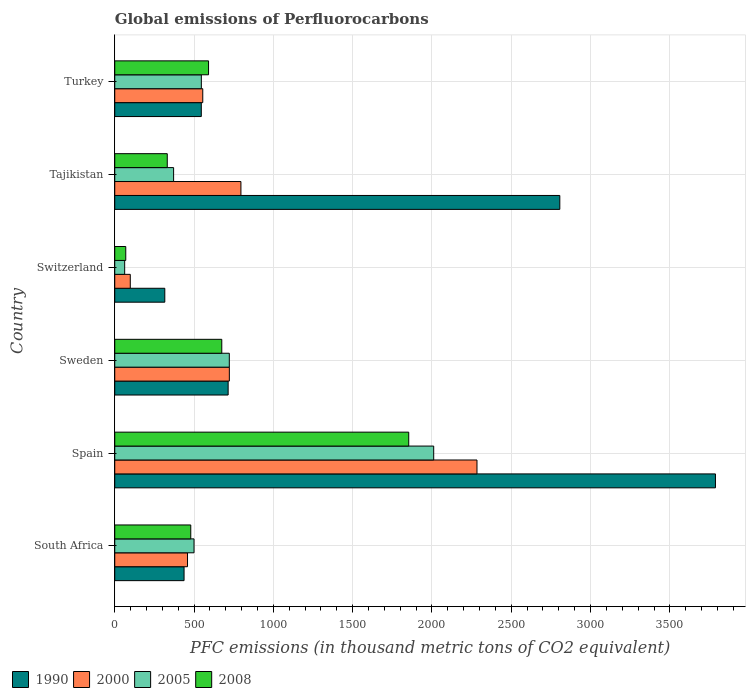Are the number of bars per tick equal to the number of legend labels?
Offer a terse response. Yes. Are the number of bars on each tick of the Y-axis equal?
Ensure brevity in your answer.  Yes. How many bars are there on the 1st tick from the top?
Offer a very short reply. 4. What is the label of the 2nd group of bars from the top?
Ensure brevity in your answer.  Tajikistan. What is the global emissions of Perfluorocarbons in 2000 in South Africa?
Your answer should be compact. 458.8. Across all countries, what is the maximum global emissions of Perfluorocarbons in 2008?
Offer a very short reply. 1853.5. Across all countries, what is the minimum global emissions of Perfluorocarbons in 2000?
Your answer should be compact. 97.9. In which country was the global emissions of Perfluorocarbons in 1990 maximum?
Give a very brief answer. Spain. In which country was the global emissions of Perfluorocarbons in 2008 minimum?
Your answer should be compact. Switzerland. What is the total global emissions of Perfluorocarbons in 1990 in the graph?
Your response must be concise. 8606.5. What is the difference between the global emissions of Perfluorocarbons in 2008 in Tajikistan and that in Turkey?
Offer a terse response. -260.3. What is the difference between the global emissions of Perfluorocarbons in 1990 in Turkey and the global emissions of Perfluorocarbons in 2005 in South Africa?
Make the answer very short. 45.8. What is the average global emissions of Perfluorocarbons in 1990 per country?
Your answer should be compact. 1434.42. What is the ratio of the global emissions of Perfluorocarbons in 2005 in South Africa to that in Tajikistan?
Ensure brevity in your answer.  1.35. Is the difference between the global emissions of Perfluorocarbons in 2005 in Tajikistan and Turkey greater than the difference between the global emissions of Perfluorocarbons in 2008 in Tajikistan and Turkey?
Provide a short and direct response. Yes. What is the difference between the highest and the second highest global emissions of Perfluorocarbons in 2000?
Your response must be concise. 1488.3. What is the difference between the highest and the lowest global emissions of Perfluorocarbons in 1990?
Your response must be concise. 3471.9. In how many countries, is the global emissions of Perfluorocarbons in 2000 greater than the average global emissions of Perfluorocarbons in 2000 taken over all countries?
Keep it short and to the point. 1. Is the sum of the global emissions of Perfluorocarbons in 2005 in Spain and Turkey greater than the maximum global emissions of Perfluorocarbons in 2000 across all countries?
Make the answer very short. Yes. What does the 4th bar from the top in South Africa represents?
Provide a succinct answer. 1990. What does the 4th bar from the bottom in Turkey represents?
Make the answer very short. 2008. How many bars are there?
Your response must be concise. 24. Does the graph contain grids?
Your response must be concise. Yes. Where does the legend appear in the graph?
Give a very brief answer. Bottom left. How many legend labels are there?
Provide a succinct answer. 4. What is the title of the graph?
Provide a short and direct response. Global emissions of Perfluorocarbons. What is the label or title of the X-axis?
Offer a terse response. PFC emissions (in thousand metric tons of CO2 equivalent). What is the PFC emissions (in thousand metric tons of CO2 equivalent) of 1990 in South Africa?
Your response must be concise. 437. What is the PFC emissions (in thousand metric tons of CO2 equivalent) in 2000 in South Africa?
Provide a short and direct response. 458.8. What is the PFC emissions (in thousand metric tons of CO2 equivalent) of 2005 in South Africa?
Offer a terse response. 499.8. What is the PFC emissions (in thousand metric tons of CO2 equivalent) in 2008 in South Africa?
Your answer should be very brief. 479.2. What is the PFC emissions (in thousand metric tons of CO2 equivalent) of 1990 in Spain?
Keep it short and to the point. 3787.4. What is the PFC emissions (in thousand metric tons of CO2 equivalent) of 2000 in Spain?
Make the answer very short. 2283.8. What is the PFC emissions (in thousand metric tons of CO2 equivalent) of 2005 in Spain?
Offer a terse response. 2011. What is the PFC emissions (in thousand metric tons of CO2 equivalent) in 2008 in Spain?
Your response must be concise. 1853.5. What is the PFC emissions (in thousand metric tons of CO2 equivalent) of 1990 in Sweden?
Make the answer very short. 714.9. What is the PFC emissions (in thousand metric tons of CO2 equivalent) in 2000 in Sweden?
Your response must be concise. 722.5. What is the PFC emissions (in thousand metric tons of CO2 equivalent) of 2005 in Sweden?
Provide a short and direct response. 722.3. What is the PFC emissions (in thousand metric tons of CO2 equivalent) of 2008 in Sweden?
Give a very brief answer. 674.8. What is the PFC emissions (in thousand metric tons of CO2 equivalent) in 1990 in Switzerland?
Your answer should be very brief. 315.5. What is the PFC emissions (in thousand metric tons of CO2 equivalent) in 2000 in Switzerland?
Your answer should be compact. 97.9. What is the PFC emissions (in thousand metric tons of CO2 equivalent) in 2005 in Switzerland?
Provide a short and direct response. 62.5. What is the PFC emissions (in thousand metric tons of CO2 equivalent) in 2008 in Switzerland?
Offer a very short reply. 69.4. What is the PFC emissions (in thousand metric tons of CO2 equivalent) in 1990 in Tajikistan?
Ensure brevity in your answer.  2806.1. What is the PFC emissions (in thousand metric tons of CO2 equivalent) in 2000 in Tajikistan?
Your response must be concise. 795.5. What is the PFC emissions (in thousand metric tons of CO2 equivalent) of 2005 in Tajikistan?
Provide a short and direct response. 371.1. What is the PFC emissions (in thousand metric tons of CO2 equivalent) of 2008 in Tajikistan?
Make the answer very short. 331.1. What is the PFC emissions (in thousand metric tons of CO2 equivalent) of 1990 in Turkey?
Your response must be concise. 545.6. What is the PFC emissions (in thousand metric tons of CO2 equivalent) of 2000 in Turkey?
Your answer should be very brief. 554.9. What is the PFC emissions (in thousand metric tons of CO2 equivalent) of 2005 in Turkey?
Offer a very short reply. 545.9. What is the PFC emissions (in thousand metric tons of CO2 equivalent) in 2008 in Turkey?
Keep it short and to the point. 591.4. Across all countries, what is the maximum PFC emissions (in thousand metric tons of CO2 equivalent) in 1990?
Give a very brief answer. 3787.4. Across all countries, what is the maximum PFC emissions (in thousand metric tons of CO2 equivalent) of 2000?
Offer a very short reply. 2283.8. Across all countries, what is the maximum PFC emissions (in thousand metric tons of CO2 equivalent) of 2005?
Your answer should be very brief. 2011. Across all countries, what is the maximum PFC emissions (in thousand metric tons of CO2 equivalent) of 2008?
Provide a succinct answer. 1853.5. Across all countries, what is the minimum PFC emissions (in thousand metric tons of CO2 equivalent) of 1990?
Ensure brevity in your answer.  315.5. Across all countries, what is the minimum PFC emissions (in thousand metric tons of CO2 equivalent) in 2000?
Offer a very short reply. 97.9. Across all countries, what is the minimum PFC emissions (in thousand metric tons of CO2 equivalent) in 2005?
Ensure brevity in your answer.  62.5. Across all countries, what is the minimum PFC emissions (in thousand metric tons of CO2 equivalent) of 2008?
Provide a succinct answer. 69.4. What is the total PFC emissions (in thousand metric tons of CO2 equivalent) of 1990 in the graph?
Make the answer very short. 8606.5. What is the total PFC emissions (in thousand metric tons of CO2 equivalent) in 2000 in the graph?
Your response must be concise. 4913.4. What is the total PFC emissions (in thousand metric tons of CO2 equivalent) of 2005 in the graph?
Provide a succinct answer. 4212.6. What is the total PFC emissions (in thousand metric tons of CO2 equivalent) of 2008 in the graph?
Your answer should be very brief. 3999.4. What is the difference between the PFC emissions (in thousand metric tons of CO2 equivalent) of 1990 in South Africa and that in Spain?
Your answer should be compact. -3350.4. What is the difference between the PFC emissions (in thousand metric tons of CO2 equivalent) in 2000 in South Africa and that in Spain?
Give a very brief answer. -1825. What is the difference between the PFC emissions (in thousand metric tons of CO2 equivalent) in 2005 in South Africa and that in Spain?
Give a very brief answer. -1511.2. What is the difference between the PFC emissions (in thousand metric tons of CO2 equivalent) in 2008 in South Africa and that in Spain?
Your response must be concise. -1374.3. What is the difference between the PFC emissions (in thousand metric tons of CO2 equivalent) in 1990 in South Africa and that in Sweden?
Offer a terse response. -277.9. What is the difference between the PFC emissions (in thousand metric tons of CO2 equivalent) in 2000 in South Africa and that in Sweden?
Give a very brief answer. -263.7. What is the difference between the PFC emissions (in thousand metric tons of CO2 equivalent) in 2005 in South Africa and that in Sweden?
Keep it short and to the point. -222.5. What is the difference between the PFC emissions (in thousand metric tons of CO2 equivalent) in 2008 in South Africa and that in Sweden?
Keep it short and to the point. -195.6. What is the difference between the PFC emissions (in thousand metric tons of CO2 equivalent) of 1990 in South Africa and that in Switzerland?
Offer a terse response. 121.5. What is the difference between the PFC emissions (in thousand metric tons of CO2 equivalent) of 2000 in South Africa and that in Switzerland?
Your answer should be very brief. 360.9. What is the difference between the PFC emissions (in thousand metric tons of CO2 equivalent) in 2005 in South Africa and that in Switzerland?
Keep it short and to the point. 437.3. What is the difference between the PFC emissions (in thousand metric tons of CO2 equivalent) of 2008 in South Africa and that in Switzerland?
Keep it short and to the point. 409.8. What is the difference between the PFC emissions (in thousand metric tons of CO2 equivalent) in 1990 in South Africa and that in Tajikistan?
Ensure brevity in your answer.  -2369.1. What is the difference between the PFC emissions (in thousand metric tons of CO2 equivalent) in 2000 in South Africa and that in Tajikistan?
Keep it short and to the point. -336.7. What is the difference between the PFC emissions (in thousand metric tons of CO2 equivalent) of 2005 in South Africa and that in Tajikistan?
Offer a very short reply. 128.7. What is the difference between the PFC emissions (in thousand metric tons of CO2 equivalent) of 2008 in South Africa and that in Tajikistan?
Provide a short and direct response. 148.1. What is the difference between the PFC emissions (in thousand metric tons of CO2 equivalent) of 1990 in South Africa and that in Turkey?
Offer a very short reply. -108.6. What is the difference between the PFC emissions (in thousand metric tons of CO2 equivalent) of 2000 in South Africa and that in Turkey?
Provide a succinct answer. -96.1. What is the difference between the PFC emissions (in thousand metric tons of CO2 equivalent) of 2005 in South Africa and that in Turkey?
Ensure brevity in your answer.  -46.1. What is the difference between the PFC emissions (in thousand metric tons of CO2 equivalent) of 2008 in South Africa and that in Turkey?
Offer a very short reply. -112.2. What is the difference between the PFC emissions (in thousand metric tons of CO2 equivalent) of 1990 in Spain and that in Sweden?
Ensure brevity in your answer.  3072.5. What is the difference between the PFC emissions (in thousand metric tons of CO2 equivalent) in 2000 in Spain and that in Sweden?
Offer a very short reply. 1561.3. What is the difference between the PFC emissions (in thousand metric tons of CO2 equivalent) in 2005 in Spain and that in Sweden?
Provide a short and direct response. 1288.7. What is the difference between the PFC emissions (in thousand metric tons of CO2 equivalent) of 2008 in Spain and that in Sweden?
Ensure brevity in your answer.  1178.7. What is the difference between the PFC emissions (in thousand metric tons of CO2 equivalent) of 1990 in Spain and that in Switzerland?
Your answer should be compact. 3471.9. What is the difference between the PFC emissions (in thousand metric tons of CO2 equivalent) in 2000 in Spain and that in Switzerland?
Provide a succinct answer. 2185.9. What is the difference between the PFC emissions (in thousand metric tons of CO2 equivalent) of 2005 in Spain and that in Switzerland?
Your answer should be compact. 1948.5. What is the difference between the PFC emissions (in thousand metric tons of CO2 equivalent) in 2008 in Spain and that in Switzerland?
Offer a terse response. 1784.1. What is the difference between the PFC emissions (in thousand metric tons of CO2 equivalent) of 1990 in Spain and that in Tajikistan?
Provide a succinct answer. 981.3. What is the difference between the PFC emissions (in thousand metric tons of CO2 equivalent) of 2000 in Spain and that in Tajikistan?
Provide a succinct answer. 1488.3. What is the difference between the PFC emissions (in thousand metric tons of CO2 equivalent) in 2005 in Spain and that in Tajikistan?
Keep it short and to the point. 1639.9. What is the difference between the PFC emissions (in thousand metric tons of CO2 equivalent) of 2008 in Spain and that in Tajikistan?
Give a very brief answer. 1522.4. What is the difference between the PFC emissions (in thousand metric tons of CO2 equivalent) in 1990 in Spain and that in Turkey?
Make the answer very short. 3241.8. What is the difference between the PFC emissions (in thousand metric tons of CO2 equivalent) of 2000 in Spain and that in Turkey?
Your answer should be compact. 1728.9. What is the difference between the PFC emissions (in thousand metric tons of CO2 equivalent) in 2005 in Spain and that in Turkey?
Keep it short and to the point. 1465.1. What is the difference between the PFC emissions (in thousand metric tons of CO2 equivalent) of 2008 in Spain and that in Turkey?
Offer a very short reply. 1262.1. What is the difference between the PFC emissions (in thousand metric tons of CO2 equivalent) in 1990 in Sweden and that in Switzerland?
Offer a very short reply. 399.4. What is the difference between the PFC emissions (in thousand metric tons of CO2 equivalent) in 2000 in Sweden and that in Switzerland?
Your response must be concise. 624.6. What is the difference between the PFC emissions (in thousand metric tons of CO2 equivalent) in 2005 in Sweden and that in Switzerland?
Offer a very short reply. 659.8. What is the difference between the PFC emissions (in thousand metric tons of CO2 equivalent) in 2008 in Sweden and that in Switzerland?
Your answer should be very brief. 605.4. What is the difference between the PFC emissions (in thousand metric tons of CO2 equivalent) in 1990 in Sweden and that in Tajikistan?
Your response must be concise. -2091.2. What is the difference between the PFC emissions (in thousand metric tons of CO2 equivalent) in 2000 in Sweden and that in Tajikistan?
Give a very brief answer. -73. What is the difference between the PFC emissions (in thousand metric tons of CO2 equivalent) of 2005 in Sweden and that in Tajikistan?
Provide a short and direct response. 351.2. What is the difference between the PFC emissions (in thousand metric tons of CO2 equivalent) of 2008 in Sweden and that in Tajikistan?
Your answer should be compact. 343.7. What is the difference between the PFC emissions (in thousand metric tons of CO2 equivalent) of 1990 in Sweden and that in Turkey?
Make the answer very short. 169.3. What is the difference between the PFC emissions (in thousand metric tons of CO2 equivalent) of 2000 in Sweden and that in Turkey?
Make the answer very short. 167.6. What is the difference between the PFC emissions (in thousand metric tons of CO2 equivalent) in 2005 in Sweden and that in Turkey?
Your answer should be very brief. 176.4. What is the difference between the PFC emissions (in thousand metric tons of CO2 equivalent) in 2008 in Sweden and that in Turkey?
Provide a succinct answer. 83.4. What is the difference between the PFC emissions (in thousand metric tons of CO2 equivalent) in 1990 in Switzerland and that in Tajikistan?
Offer a terse response. -2490.6. What is the difference between the PFC emissions (in thousand metric tons of CO2 equivalent) in 2000 in Switzerland and that in Tajikistan?
Your response must be concise. -697.6. What is the difference between the PFC emissions (in thousand metric tons of CO2 equivalent) in 2005 in Switzerland and that in Tajikistan?
Your response must be concise. -308.6. What is the difference between the PFC emissions (in thousand metric tons of CO2 equivalent) of 2008 in Switzerland and that in Tajikistan?
Provide a short and direct response. -261.7. What is the difference between the PFC emissions (in thousand metric tons of CO2 equivalent) in 1990 in Switzerland and that in Turkey?
Make the answer very short. -230.1. What is the difference between the PFC emissions (in thousand metric tons of CO2 equivalent) of 2000 in Switzerland and that in Turkey?
Your answer should be very brief. -457. What is the difference between the PFC emissions (in thousand metric tons of CO2 equivalent) in 2005 in Switzerland and that in Turkey?
Your answer should be very brief. -483.4. What is the difference between the PFC emissions (in thousand metric tons of CO2 equivalent) in 2008 in Switzerland and that in Turkey?
Ensure brevity in your answer.  -522. What is the difference between the PFC emissions (in thousand metric tons of CO2 equivalent) in 1990 in Tajikistan and that in Turkey?
Offer a very short reply. 2260.5. What is the difference between the PFC emissions (in thousand metric tons of CO2 equivalent) of 2000 in Tajikistan and that in Turkey?
Your answer should be very brief. 240.6. What is the difference between the PFC emissions (in thousand metric tons of CO2 equivalent) in 2005 in Tajikistan and that in Turkey?
Your answer should be very brief. -174.8. What is the difference between the PFC emissions (in thousand metric tons of CO2 equivalent) in 2008 in Tajikistan and that in Turkey?
Offer a very short reply. -260.3. What is the difference between the PFC emissions (in thousand metric tons of CO2 equivalent) in 1990 in South Africa and the PFC emissions (in thousand metric tons of CO2 equivalent) in 2000 in Spain?
Keep it short and to the point. -1846.8. What is the difference between the PFC emissions (in thousand metric tons of CO2 equivalent) in 1990 in South Africa and the PFC emissions (in thousand metric tons of CO2 equivalent) in 2005 in Spain?
Your answer should be very brief. -1574. What is the difference between the PFC emissions (in thousand metric tons of CO2 equivalent) of 1990 in South Africa and the PFC emissions (in thousand metric tons of CO2 equivalent) of 2008 in Spain?
Give a very brief answer. -1416.5. What is the difference between the PFC emissions (in thousand metric tons of CO2 equivalent) of 2000 in South Africa and the PFC emissions (in thousand metric tons of CO2 equivalent) of 2005 in Spain?
Your answer should be very brief. -1552.2. What is the difference between the PFC emissions (in thousand metric tons of CO2 equivalent) of 2000 in South Africa and the PFC emissions (in thousand metric tons of CO2 equivalent) of 2008 in Spain?
Make the answer very short. -1394.7. What is the difference between the PFC emissions (in thousand metric tons of CO2 equivalent) of 2005 in South Africa and the PFC emissions (in thousand metric tons of CO2 equivalent) of 2008 in Spain?
Give a very brief answer. -1353.7. What is the difference between the PFC emissions (in thousand metric tons of CO2 equivalent) of 1990 in South Africa and the PFC emissions (in thousand metric tons of CO2 equivalent) of 2000 in Sweden?
Your response must be concise. -285.5. What is the difference between the PFC emissions (in thousand metric tons of CO2 equivalent) of 1990 in South Africa and the PFC emissions (in thousand metric tons of CO2 equivalent) of 2005 in Sweden?
Your response must be concise. -285.3. What is the difference between the PFC emissions (in thousand metric tons of CO2 equivalent) of 1990 in South Africa and the PFC emissions (in thousand metric tons of CO2 equivalent) of 2008 in Sweden?
Your answer should be very brief. -237.8. What is the difference between the PFC emissions (in thousand metric tons of CO2 equivalent) of 2000 in South Africa and the PFC emissions (in thousand metric tons of CO2 equivalent) of 2005 in Sweden?
Offer a terse response. -263.5. What is the difference between the PFC emissions (in thousand metric tons of CO2 equivalent) in 2000 in South Africa and the PFC emissions (in thousand metric tons of CO2 equivalent) in 2008 in Sweden?
Make the answer very short. -216. What is the difference between the PFC emissions (in thousand metric tons of CO2 equivalent) in 2005 in South Africa and the PFC emissions (in thousand metric tons of CO2 equivalent) in 2008 in Sweden?
Offer a terse response. -175. What is the difference between the PFC emissions (in thousand metric tons of CO2 equivalent) in 1990 in South Africa and the PFC emissions (in thousand metric tons of CO2 equivalent) in 2000 in Switzerland?
Your answer should be compact. 339.1. What is the difference between the PFC emissions (in thousand metric tons of CO2 equivalent) in 1990 in South Africa and the PFC emissions (in thousand metric tons of CO2 equivalent) in 2005 in Switzerland?
Give a very brief answer. 374.5. What is the difference between the PFC emissions (in thousand metric tons of CO2 equivalent) of 1990 in South Africa and the PFC emissions (in thousand metric tons of CO2 equivalent) of 2008 in Switzerland?
Provide a succinct answer. 367.6. What is the difference between the PFC emissions (in thousand metric tons of CO2 equivalent) in 2000 in South Africa and the PFC emissions (in thousand metric tons of CO2 equivalent) in 2005 in Switzerland?
Provide a succinct answer. 396.3. What is the difference between the PFC emissions (in thousand metric tons of CO2 equivalent) in 2000 in South Africa and the PFC emissions (in thousand metric tons of CO2 equivalent) in 2008 in Switzerland?
Your answer should be very brief. 389.4. What is the difference between the PFC emissions (in thousand metric tons of CO2 equivalent) of 2005 in South Africa and the PFC emissions (in thousand metric tons of CO2 equivalent) of 2008 in Switzerland?
Your response must be concise. 430.4. What is the difference between the PFC emissions (in thousand metric tons of CO2 equivalent) in 1990 in South Africa and the PFC emissions (in thousand metric tons of CO2 equivalent) in 2000 in Tajikistan?
Ensure brevity in your answer.  -358.5. What is the difference between the PFC emissions (in thousand metric tons of CO2 equivalent) in 1990 in South Africa and the PFC emissions (in thousand metric tons of CO2 equivalent) in 2005 in Tajikistan?
Make the answer very short. 65.9. What is the difference between the PFC emissions (in thousand metric tons of CO2 equivalent) of 1990 in South Africa and the PFC emissions (in thousand metric tons of CO2 equivalent) of 2008 in Tajikistan?
Ensure brevity in your answer.  105.9. What is the difference between the PFC emissions (in thousand metric tons of CO2 equivalent) of 2000 in South Africa and the PFC emissions (in thousand metric tons of CO2 equivalent) of 2005 in Tajikistan?
Your response must be concise. 87.7. What is the difference between the PFC emissions (in thousand metric tons of CO2 equivalent) in 2000 in South Africa and the PFC emissions (in thousand metric tons of CO2 equivalent) in 2008 in Tajikistan?
Ensure brevity in your answer.  127.7. What is the difference between the PFC emissions (in thousand metric tons of CO2 equivalent) in 2005 in South Africa and the PFC emissions (in thousand metric tons of CO2 equivalent) in 2008 in Tajikistan?
Make the answer very short. 168.7. What is the difference between the PFC emissions (in thousand metric tons of CO2 equivalent) of 1990 in South Africa and the PFC emissions (in thousand metric tons of CO2 equivalent) of 2000 in Turkey?
Your answer should be very brief. -117.9. What is the difference between the PFC emissions (in thousand metric tons of CO2 equivalent) of 1990 in South Africa and the PFC emissions (in thousand metric tons of CO2 equivalent) of 2005 in Turkey?
Offer a terse response. -108.9. What is the difference between the PFC emissions (in thousand metric tons of CO2 equivalent) in 1990 in South Africa and the PFC emissions (in thousand metric tons of CO2 equivalent) in 2008 in Turkey?
Your answer should be compact. -154.4. What is the difference between the PFC emissions (in thousand metric tons of CO2 equivalent) in 2000 in South Africa and the PFC emissions (in thousand metric tons of CO2 equivalent) in 2005 in Turkey?
Ensure brevity in your answer.  -87.1. What is the difference between the PFC emissions (in thousand metric tons of CO2 equivalent) of 2000 in South Africa and the PFC emissions (in thousand metric tons of CO2 equivalent) of 2008 in Turkey?
Keep it short and to the point. -132.6. What is the difference between the PFC emissions (in thousand metric tons of CO2 equivalent) in 2005 in South Africa and the PFC emissions (in thousand metric tons of CO2 equivalent) in 2008 in Turkey?
Your answer should be compact. -91.6. What is the difference between the PFC emissions (in thousand metric tons of CO2 equivalent) of 1990 in Spain and the PFC emissions (in thousand metric tons of CO2 equivalent) of 2000 in Sweden?
Ensure brevity in your answer.  3064.9. What is the difference between the PFC emissions (in thousand metric tons of CO2 equivalent) of 1990 in Spain and the PFC emissions (in thousand metric tons of CO2 equivalent) of 2005 in Sweden?
Ensure brevity in your answer.  3065.1. What is the difference between the PFC emissions (in thousand metric tons of CO2 equivalent) in 1990 in Spain and the PFC emissions (in thousand metric tons of CO2 equivalent) in 2008 in Sweden?
Your answer should be very brief. 3112.6. What is the difference between the PFC emissions (in thousand metric tons of CO2 equivalent) in 2000 in Spain and the PFC emissions (in thousand metric tons of CO2 equivalent) in 2005 in Sweden?
Ensure brevity in your answer.  1561.5. What is the difference between the PFC emissions (in thousand metric tons of CO2 equivalent) in 2000 in Spain and the PFC emissions (in thousand metric tons of CO2 equivalent) in 2008 in Sweden?
Make the answer very short. 1609. What is the difference between the PFC emissions (in thousand metric tons of CO2 equivalent) in 2005 in Spain and the PFC emissions (in thousand metric tons of CO2 equivalent) in 2008 in Sweden?
Your answer should be compact. 1336.2. What is the difference between the PFC emissions (in thousand metric tons of CO2 equivalent) of 1990 in Spain and the PFC emissions (in thousand metric tons of CO2 equivalent) of 2000 in Switzerland?
Your answer should be very brief. 3689.5. What is the difference between the PFC emissions (in thousand metric tons of CO2 equivalent) in 1990 in Spain and the PFC emissions (in thousand metric tons of CO2 equivalent) in 2005 in Switzerland?
Keep it short and to the point. 3724.9. What is the difference between the PFC emissions (in thousand metric tons of CO2 equivalent) in 1990 in Spain and the PFC emissions (in thousand metric tons of CO2 equivalent) in 2008 in Switzerland?
Give a very brief answer. 3718. What is the difference between the PFC emissions (in thousand metric tons of CO2 equivalent) in 2000 in Spain and the PFC emissions (in thousand metric tons of CO2 equivalent) in 2005 in Switzerland?
Your response must be concise. 2221.3. What is the difference between the PFC emissions (in thousand metric tons of CO2 equivalent) of 2000 in Spain and the PFC emissions (in thousand metric tons of CO2 equivalent) of 2008 in Switzerland?
Offer a very short reply. 2214.4. What is the difference between the PFC emissions (in thousand metric tons of CO2 equivalent) of 2005 in Spain and the PFC emissions (in thousand metric tons of CO2 equivalent) of 2008 in Switzerland?
Provide a short and direct response. 1941.6. What is the difference between the PFC emissions (in thousand metric tons of CO2 equivalent) of 1990 in Spain and the PFC emissions (in thousand metric tons of CO2 equivalent) of 2000 in Tajikistan?
Provide a short and direct response. 2991.9. What is the difference between the PFC emissions (in thousand metric tons of CO2 equivalent) of 1990 in Spain and the PFC emissions (in thousand metric tons of CO2 equivalent) of 2005 in Tajikistan?
Your answer should be very brief. 3416.3. What is the difference between the PFC emissions (in thousand metric tons of CO2 equivalent) of 1990 in Spain and the PFC emissions (in thousand metric tons of CO2 equivalent) of 2008 in Tajikistan?
Keep it short and to the point. 3456.3. What is the difference between the PFC emissions (in thousand metric tons of CO2 equivalent) of 2000 in Spain and the PFC emissions (in thousand metric tons of CO2 equivalent) of 2005 in Tajikistan?
Offer a terse response. 1912.7. What is the difference between the PFC emissions (in thousand metric tons of CO2 equivalent) of 2000 in Spain and the PFC emissions (in thousand metric tons of CO2 equivalent) of 2008 in Tajikistan?
Your answer should be very brief. 1952.7. What is the difference between the PFC emissions (in thousand metric tons of CO2 equivalent) in 2005 in Spain and the PFC emissions (in thousand metric tons of CO2 equivalent) in 2008 in Tajikistan?
Provide a succinct answer. 1679.9. What is the difference between the PFC emissions (in thousand metric tons of CO2 equivalent) in 1990 in Spain and the PFC emissions (in thousand metric tons of CO2 equivalent) in 2000 in Turkey?
Offer a terse response. 3232.5. What is the difference between the PFC emissions (in thousand metric tons of CO2 equivalent) of 1990 in Spain and the PFC emissions (in thousand metric tons of CO2 equivalent) of 2005 in Turkey?
Provide a short and direct response. 3241.5. What is the difference between the PFC emissions (in thousand metric tons of CO2 equivalent) in 1990 in Spain and the PFC emissions (in thousand metric tons of CO2 equivalent) in 2008 in Turkey?
Your answer should be compact. 3196. What is the difference between the PFC emissions (in thousand metric tons of CO2 equivalent) in 2000 in Spain and the PFC emissions (in thousand metric tons of CO2 equivalent) in 2005 in Turkey?
Ensure brevity in your answer.  1737.9. What is the difference between the PFC emissions (in thousand metric tons of CO2 equivalent) in 2000 in Spain and the PFC emissions (in thousand metric tons of CO2 equivalent) in 2008 in Turkey?
Your answer should be very brief. 1692.4. What is the difference between the PFC emissions (in thousand metric tons of CO2 equivalent) of 2005 in Spain and the PFC emissions (in thousand metric tons of CO2 equivalent) of 2008 in Turkey?
Ensure brevity in your answer.  1419.6. What is the difference between the PFC emissions (in thousand metric tons of CO2 equivalent) of 1990 in Sweden and the PFC emissions (in thousand metric tons of CO2 equivalent) of 2000 in Switzerland?
Keep it short and to the point. 617. What is the difference between the PFC emissions (in thousand metric tons of CO2 equivalent) in 1990 in Sweden and the PFC emissions (in thousand metric tons of CO2 equivalent) in 2005 in Switzerland?
Your response must be concise. 652.4. What is the difference between the PFC emissions (in thousand metric tons of CO2 equivalent) of 1990 in Sweden and the PFC emissions (in thousand metric tons of CO2 equivalent) of 2008 in Switzerland?
Make the answer very short. 645.5. What is the difference between the PFC emissions (in thousand metric tons of CO2 equivalent) in 2000 in Sweden and the PFC emissions (in thousand metric tons of CO2 equivalent) in 2005 in Switzerland?
Give a very brief answer. 660. What is the difference between the PFC emissions (in thousand metric tons of CO2 equivalent) in 2000 in Sweden and the PFC emissions (in thousand metric tons of CO2 equivalent) in 2008 in Switzerland?
Provide a short and direct response. 653.1. What is the difference between the PFC emissions (in thousand metric tons of CO2 equivalent) in 2005 in Sweden and the PFC emissions (in thousand metric tons of CO2 equivalent) in 2008 in Switzerland?
Offer a very short reply. 652.9. What is the difference between the PFC emissions (in thousand metric tons of CO2 equivalent) in 1990 in Sweden and the PFC emissions (in thousand metric tons of CO2 equivalent) in 2000 in Tajikistan?
Ensure brevity in your answer.  -80.6. What is the difference between the PFC emissions (in thousand metric tons of CO2 equivalent) of 1990 in Sweden and the PFC emissions (in thousand metric tons of CO2 equivalent) of 2005 in Tajikistan?
Offer a terse response. 343.8. What is the difference between the PFC emissions (in thousand metric tons of CO2 equivalent) in 1990 in Sweden and the PFC emissions (in thousand metric tons of CO2 equivalent) in 2008 in Tajikistan?
Ensure brevity in your answer.  383.8. What is the difference between the PFC emissions (in thousand metric tons of CO2 equivalent) of 2000 in Sweden and the PFC emissions (in thousand metric tons of CO2 equivalent) of 2005 in Tajikistan?
Your answer should be compact. 351.4. What is the difference between the PFC emissions (in thousand metric tons of CO2 equivalent) in 2000 in Sweden and the PFC emissions (in thousand metric tons of CO2 equivalent) in 2008 in Tajikistan?
Offer a very short reply. 391.4. What is the difference between the PFC emissions (in thousand metric tons of CO2 equivalent) in 2005 in Sweden and the PFC emissions (in thousand metric tons of CO2 equivalent) in 2008 in Tajikistan?
Give a very brief answer. 391.2. What is the difference between the PFC emissions (in thousand metric tons of CO2 equivalent) in 1990 in Sweden and the PFC emissions (in thousand metric tons of CO2 equivalent) in 2000 in Turkey?
Your answer should be compact. 160. What is the difference between the PFC emissions (in thousand metric tons of CO2 equivalent) of 1990 in Sweden and the PFC emissions (in thousand metric tons of CO2 equivalent) of 2005 in Turkey?
Your response must be concise. 169. What is the difference between the PFC emissions (in thousand metric tons of CO2 equivalent) in 1990 in Sweden and the PFC emissions (in thousand metric tons of CO2 equivalent) in 2008 in Turkey?
Ensure brevity in your answer.  123.5. What is the difference between the PFC emissions (in thousand metric tons of CO2 equivalent) in 2000 in Sweden and the PFC emissions (in thousand metric tons of CO2 equivalent) in 2005 in Turkey?
Your answer should be very brief. 176.6. What is the difference between the PFC emissions (in thousand metric tons of CO2 equivalent) of 2000 in Sweden and the PFC emissions (in thousand metric tons of CO2 equivalent) of 2008 in Turkey?
Your answer should be compact. 131.1. What is the difference between the PFC emissions (in thousand metric tons of CO2 equivalent) of 2005 in Sweden and the PFC emissions (in thousand metric tons of CO2 equivalent) of 2008 in Turkey?
Provide a short and direct response. 130.9. What is the difference between the PFC emissions (in thousand metric tons of CO2 equivalent) in 1990 in Switzerland and the PFC emissions (in thousand metric tons of CO2 equivalent) in 2000 in Tajikistan?
Make the answer very short. -480. What is the difference between the PFC emissions (in thousand metric tons of CO2 equivalent) in 1990 in Switzerland and the PFC emissions (in thousand metric tons of CO2 equivalent) in 2005 in Tajikistan?
Keep it short and to the point. -55.6. What is the difference between the PFC emissions (in thousand metric tons of CO2 equivalent) of 1990 in Switzerland and the PFC emissions (in thousand metric tons of CO2 equivalent) of 2008 in Tajikistan?
Give a very brief answer. -15.6. What is the difference between the PFC emissions (in thousand metric tons of CO2 equivalent) in 2000 in Switzerland and the PFC emissions (in thousand metric tons of CO2 equivalent) in 2005 in Tajikistan?
Give a very brief answer. -273.2. What is the difference between the PFC emissions (in thousand metric tons of CO2 equivalent) in 2000 in Switzerland and the PFC emissions (in thousand metric tons of CO2 equivalent) in 2008 in Tajikistan?
Provide a succinct answer. -233.2. What is the difference between the PFC emissions (in thousand metric tons of CO2 equivalent) in 2005 in Switzerland and the PFC emissions (in thousand metric tons of CO2 equivalent) in 2008 in Tajikistan?
Give a very brief answer. -268.6. What is the difference between the PFC emissions (in thousand metric tons of CO2 equivalent) of 1990 in Switzerland and the PFC emissions (in thousand metric tons of CO2 equivalent) of 2000 in Turkey?
Your answer should be very brief. -239.4. What is the difference between the PFC emissions (in thousand metric tons of CO2 equivalent) in 1990 in Switzerland and the PFC emissions (in thousand metric tons of CO2 equivalent) in 2005 in Turkey?
Keep it short and to the point. -230.4. What is the difference between the PFC emissions (in thousand metric tons of CO2 equivalent) of 1990 in Switzerland and the PFC emissions (in thousand metric tons of CO2 equivalent) of 2008 in Turkey?
Keep it short and to the point. -275.9. What is the difference between the PFC emissions (in thousand metric tons of CO2 equivalent) in 2000 in Switzerland and the PFC emissions (in thousand metric tons of CO2 equivalent) in 2005 in Turkey?
Give a very brief answer. -448. What is the difference between the PFC emissions (in thousand metric tons of CO2 equivalent) in 2000 in Switzerland and the PFC emissions (in thousand metric tons of CO2 equivalent) in 2008 in Turkey?
Make the answer very short. -493.5. What is the difference between the PFC emissions (in thousand metric tons of CO2 equivalent) of 2005 in Switzerland and the PFC emissions (in thousand metric tons of CO2 equivalent) of 2008 in Turkey?
Offer a very short reply. -528.9. What is the difference between the PFC emissions (in thousand metric tons of CO2 equivalent) of 1990 in Tajikistan and the PFC emissions (in thousand metric tons of CO2 equivalent) of 2000 in Turkey?
Ensure brevity in your answer.  2251.2. What is the difference between the PFC emissions (in thousand metric tons of CO2 equivalent) of 1990 in Tajikistan and the PFC emissions (in thousand metric tons of CO2 equivalent) of 2005 in Turkey?
Make the answer very short. 2260.2. What is the difference between the PFC emissions (in thousand metric tons of CO2 equivalent) of 1990 in Tajikistan and the PFC emissions (in thousand metric tons of CO2 equivalent) of 2008 in Turkey?
Make the answer very short. 2214.7. What is the difference between the PFC emissions (in thousand metric tons of CO2 equivalent) in 2000 in Tajikistan and the PFC emissions (in thousand metric tons of CO2 equivalent) in 2005 in Turkey?
Your answer should be compact. 249.6. What is the difference between the PFC emissions (in thousand metric tons of CO2 equivalent) of 2000 in Tajikistan and the PFC emissions (in thousand metric tons of CO2 equivalent) of 2008 in Turkey?
Make the answer very short. 204.1. What is the difference between the PFC emissions (in thousand metric tons of CO2 equivalent) of 2005 in Tajikistan and the PFC emissions (in thousand metric tons of CO2 equivalent) of 2008 in Turkey?
Offer a very short reply. -220.3. What is the average PFC emissions (in thousand metric tons of CO2 equivalent) in 1990 per country?
Offer a terse response. 1434.42. What is the average PFC emissions (in thousand metric tons of CO2 equivalent) of 2000 per country?
Your response must be concise. 818.9. What is the average PFC emissions (in thousand metric tons of CO2 equivalent) in 2005 per country?
Make the answer very short. 702.1. What is the average PFC emissions (in thousand metric tons of CO2 equivalent) in 2008 per country?
Offer a terse response. 666.57. What is the difference between the PFC emissions (in thousand metric tons of CO2 equivalent) of 1990 and PFC emissions (in thousand metric tons of CO2 equivalent) of 2000 in South Africa?
Ensure brevity in your answer.  -21.8. What is the difference between the PFC emissions (in thousand metric tons of CO2 equivalent) in 1990 and PFC emissions (in thousand metric tons of CO2 equivalent) in 2005 in South Africa?
Your response must be concise. -62.8. What is the difference between the PFC emissions (in thousand metric tons of CO2 equivalent) in 1990 and PFC emissions (in thousand metric tons of CO2 equivalent) in 2008 in South Africa?
Provide a short and direct response. -42.2. What is the difference between the PFC emissions (in thousand metric tons of CO2 equivalent) in 2000 and PFC emissions (in thousand metric tons of CO2 equivalent) in 2005 in South Africa?
Give a very brief answer. -41. What is the difference between the PFC emissions (in thousand metric tons of CO2 equivalent) of 2000 and PFC emissions (in thousand metric tons of CO2 equivalent) of 2008 in South Africa?
Provide a succinct answer. -20.4. What is the difference between the PFC emissions (in thousand metric tons of CO2 equivalent) in 2005 and PFC emissions (in thousand metric tons of CO2 equivalent) in 2008 in South Africa?
Provide a succinct answer. 20.6. What is the difference between the PFC emissions (in thousand metric tons of CO2 equivalent) of 1990 and PFC emissions (in thousand metric tons of CO2 equivalent) of 2000 in Spain?
Provide a short and direct response. 1503.6. What is the difference between the PFC emissions (in thousand metric tons of CO2 equivalent) of 1990 and PFC emissions (in thousand metric tons of CO2 equivalent) of 2005 in Spain?
Your answer should be compact. 1776.4. What is the difference between the PFC emissions (in thousand metric tons of CO2 equivalent) of 1990 and PFC emissions (in thousand metric tons of CO2 equivalent) of 2008 in Spain?
Provide a short and direct response. 1933.9. What is the difference between the PFC emissions (in thousand metric tons of CO2 equivalent) of 2000 and PFC emissions (in thousand metric tons of CO2 equivalent) of 2005 in Spain?
Provide a succinct answer. 272.8. What is the difference between the PFC emissions (in thousand metric tons of CO2 equivalent) in 2000 and PFC emissions (in thousand metric tons of CO2 equivalent) in 2008 in Spain?
Your answer should be very brief. 430.3. What is the difference between the PFC emissions (in thousand metric tons of CO2 equivalent) of 2005 and PFC emissions (in thousand metric tons of CO2 equivalent) of 2008 in Spain?
Your answer should be compact. 157.5. What is the difference between the PFC emissions (in thousand metric tons of CO2 equivalent) in 1990 and PFC emissions (in thousand metric tons of CO2 equivalent) in 2008 in Sweden?
Keep it short and to the point. 40.1. What is the difference between the PFC emissions (in thousand metric tons of CO2 equivalent) in 2000 and PFC emissions (in thousand metric tons of CO2 equivalent) in 2008 in Sweden?
Keep it short and to the point. 47.7. What is the difference between the PFC emissions (in thousand metric tons of CO2 equivalent) of 2005 and PFC emissions (in thousand metric tons of CO2 equivalent) of 2008 in Sweden?
Provide a succinct answer. 47.5. What is the difference between the PFC emissions (in thousand metric tons of CO2 equivalent) of 1990 and PFC emissions (in thousand metric tons of CO2 equivalent) of 2000 in Switzerland?
Keep it short and to the point. 217.6. What is the difference between the PFC emissions (in thousand metric tons of CO2 equivalent) in 1990 and PFC emissions (in thousand metric tons of CO2 equivalent) in 2005 in Switzerland?
Your response must be concise. 253. What is the difference between the PFC emissions (in thousand metric tons of CO2 equivalent) in 1990 and PFC emissions (in thousand metric tons of CO2 equivalent) in 2008 in Switzerland?
Your answer should be compact. 246.1. What is the difference between the PFC emissions (in thousand metric tons of CO2 equivalent) in 2000 and PFC emissions (in thousand metric tons of CO2 equivalent) in 2005 in Switzerland?
Offer a very short reply. 35.4. What is the difference between the PFC emissions (in thousand metric tons of CO2 equivalent) in 2000 and PFC emissions (in thousand metric tons of CO2 equivalent) in 2008 in Switzerland?
Ensure brevity in your answer.  28.5. What is the difference between the PFC emissions (in thousand metric tons of CO2 equivalent) of 2005 and PFC emissions (in thousand metric tons of CO2 equivalent) of 2008 in Switzerland?
Your answer should be compact. -6.9. What is the difference between the PFC emissions (in thousand metric tons of CO2 equivalent) in 1990 and PFC emissions (in thousand metric tons of CO2 equivalent) in 2000 in Tajikistan?
Make the answer very short. 2010.6. What is the difference between the PFC emissions (in thousand metric tons of CO2 equivalent) in 1990 and PFC emissions (in thousand metric tons of CO2 equivalent) in 2005 in Tajikistan?
Ensure brevity in your answer.  2435. What is the difference between the PFC emissions (in thousand metric tons of CO2 equivalent) in 1990 and PFC emissions (in thousand metric tons of CO2 equivalent) in 2008 in Tajikistan?
Make the answer very short. 2475. What is the difference between the PFC emissions (in thousand metric tons of CO2 equivalent) in 2000 and PFC emissions (in thousand metric tons of CO2 equivalent) in 2005 in Tajikistan?
Ensure brevity in your answer.  424.4. What is the difference between the PFC emissions (in thousand metric tons of CO2 equivalent) in 2000 and PFC emissions (in thousand metric tons of CO2 equivalent) in 2008 in Tajikistan?
Ensure brevity in your answer.  464.4. What is the difference between the PFC emissions (in thousand metric tons of CO2 equivalent) in 2005 and PFC emissions (in thousand metric tons of CO2 equivalent) in 2008 in Tajikistan?
Your answer should be very brief. 40. What is the difference between the PFC emissions (in thousand metric tons of CO2 equivalent) in 1990 and PFC emissions (in thousand metric tons of CO2 equivalent) in 2008 in Turkey?
Provide a succinct answer. -45.8. What is the difference between the PFC emissions (in thousand metric tons of CO2 equivalent) of 2000 and PFC emissions (in thousand metric tons of CO2 equivalent) of 2008 in Turkey?
Offer a terse response. -36.5. What is the difference between the PFC emissions (in thousand metric tons of CO2 equivalent) in 2005 and PFC emissions (in thousand metric tons of CO2 equivalent) in 2008 in Turkey?
Your response must be concise. -45.5. What is the ratio of the PFC emissions (in thousand metric tons of CO2 equivalent) of 1990 in South Africa to that in Spain?
Your answer should be compact. 0.12. What is the ratio of the PFC emissions (in thousand metric tons of CO2 equivalent) of 2000 in South Africa to that in Spain?
Provide a succinct answer. 0.2. What is the ratio of the PFC emissions (in thousand metric tons of CO2 equivalent) in 2005 in South Africa to that in Spain?
Provide a short and direct response. 0.25. What is the ratio of the PFC emissions (in thousand metric tons of CO2 equivalent) in 2008 in South Africa to that in Spain?
Provide a succinct answer. 0.26. What is the ratio of the PFC emissions (in thousand metric tons of CO2 equivalent) in 1990 in South Africa to that in Sweden?
Make the answer very short. 0.61. What is the ratio of the PFC emissions (in thousand metric tons of CO2 equivalent) of 2000 in South Africa to that in Sweden?
Keep it short and to the point. 0.64. What is the ratio of the PFC emissions (in thousand metric tons of CO2 equivalent) in 2005 in South Africa to that in Sweden?
Provide a short and direct response. 0.69. What is the ratio of the PFC emissions (in thousand metric tons of CO2 equivalent) in 2008 in South Africa to that in Sweden?
Keep it short and to the point. 0.71. What is the ratio of the PFC emissions (in thousand metric tons of CO2 equivalent) in 1990 in South Africa to that in Switzerland?
Offer a very short reply. 1.39. What is the ratio of the PFC emissions (in thousand metric tons of CO2 equivalent) of 2000 in South Africa to that in Switzerland?
Keep it short and to the point. 4.69. What is the ratio of the PFC emissions (in thousand metric tons of CO2 equivalent) of 2005 in South Africa to that in Switzerland?
Make the answer very short. 8. What is the ratio of the PFC emissions (in thousand metric tons of CO2 equivalent) of 2008 in South Africa to that in Switzerland?
Give a very brief answer. 6.9. What is the ratio of the PFC emissions (in thousand metric tons of CO2 equivalent) in 1990 in South Africa to that in Tajikistan?
Keep it short and to the point. 0.16. What is the ratio of the PFC emissions (in thousand metric tons of CO2 equivalent) in 2000 in South Africa to that in Tajikistan?
Offer a terse response. 0.58. What is the ratio of the PFC emissions (in thousand metric tons of CO2 equivalent) in 2005 in South Africa to that in Tajikistan?
Give a very brief answer. 1.35. What is the ratio of the PFC emissions (in thousand metric tons of CO2 equivalent) in 2008 in South Africa to that in Tajikistan?
Offer a terse response. 1.45. What is the ratio of the PFC emissions (in thousand metric tons of CO2 equivalent) in 1990 in South Africa to that in Turkey?
Ensure brevity in your answer.  0.8. What is the ratio of the PFC emissions (in thousand metric tons of CO2 equivalent) in 2000 in South Africa to that in Turkey?
Ensure brevity in your answer.  0.83. What is the ratio of the PFC emissions (in thousand metric tons of CO2 equivalent) of 2005 in South Africa to that in Turkey?
Offer a very short reply. 0.92. What is the ratio of the PFC emissions (in thousand metric tons of CO2 equivalent) of 2008 in South Africa to that in Turkey?
Provide a short and direct response. 0.81. What is the ratio of the PFC emissions (in thousand metric tons of CO2 equivalent) of 1990 in Spain to that in Sweden?
Keep it short and to the point. 5.3. What is the ratio of the PFC emissions (in thousand metric tons of CO2 equivalent) of 2000 in Spain to that in Sweden?
Make the answer very short. 3.16. What is the ratio of the PFC emissions (in thousand metric tons of CO2 equivalent) of 2005 in Spain to that in Sweden?
Offer a terse response. 2.78. What is the ratio of the PFC emissions (in thousand metric tons of CO2 equivalent) in 2008 in Spain to that in Sweden?
Your answer should be compact. 2.75. What is the ratio of the PFC emissions (in thousand metric tons of CO2 equivalent) of 1990 in Spain to that in Switzerland?
Offer a terse response. 12. What is the ratio of the PFC emissions (in thousand metric tons of CO2 equivalent) of 2000 in Spain to that in Switzerland?
Offer a very short reply. 23.33. What is the ratio of the PFC emissions (in thousand metric tons of CO2 equivalent) of 2005 in Spain to that in Switzerland?
Offer a terse response. 32.18. What is the ratio of the PFC emissions (in thousand metric tons of CO2 equivalent) of 2008 in Spain to that in Switzerland?
Make the answer very short. 26.71. What is the ratio of the PFC emissions (in thousand metric tons of CO2 equivalent) in 1990 in Spain to that in Tajikistan?
Ensure brevity in your answer.  1.35. What is the ratio of the PFC emissions (in thousand metric tons of CO2 equivalent) of 2000 in Spain to that in Tajikistan?
Your answer should be compact. 2.87. What is the ratio of the PFC emissions (in thousand metric tons of CO2 equivalent) in 2005 in Spain to that in Tajikistan?
Ensure brevity in your answer.  5.42. What is the ratio of the PFC emissions (in thousand metric tons of CO2 equivalent) of 2008 in Spain to that in Tajikistan?
Keep it short and to the point. 5.6. What is the ratio of the PFC emissions (in thousand metric tons of CO2 equivalent) of 1990 in Spain to that in Turkey?
Ensure brevity in your answer.  6.94. What is the ratio of the PFC emissions (in thousand metric tons of CO2 equivalent) of 2000 in Spain to that in Turkey?
Offer a terse response. 4.12. What is the ratio of the PFC emissions (in thousand metric tons of CO2 equivalent) of 2005 in Spain to that in Turkey?
Offer a very short reply. 3.68. What is the ratio of the PFC emissions (in thousand metric tons of CO2 equivalent) of 2008 in Spain to that in Turkey?
Offer a terse response. 3.13. What is the ratio of the PFC emissions (in thousand metric tons of CO2 equivalent) in 1990 in Sweden to that in Switzerland?
Provide a succinct answer. 2.27. What is the ratio of the PFC emissions (in thousand metric tons of CO2 equivalent) of 2000 in Sweden to that in Switzerland?
Make the answer very short. 7.38. What is the ratio of the PFC emissions (in thousand metric tons of CO2 equivalent) of 2005 in Sweden to that in Switzerland?
Your answer should be compact. 11.56. What is the ratio of the PFC emissions (in thousand metric tons of CO2 equivalent) of 2008 in Sweden to that in Switzerland?
Your answer should be very brief. 9.72. What is the ratio of the PFC emissions (in thousand metric tons of CO2 equivalent) in 1990 in Sweden to that in Tajikistan?
Give a very brief answer. 0.25. What is the ratio of the PFC emissions (in thousand metric tons of CO2 equivalent) in 2000 in Sweden to that in Tajikistan?
Your response must be concise. 0.91. What is the ratio of the PFC emissions (in thousand metric tons of CO2 equivalent) of 2005 in Sweden to that in Tajikistan?
Ensure brevity in your answer.  1.95. What is the ratio of the PFC emissions (in thousand metric tons of CO2 equivalent) of 2008 in Sweden to that in Tajikistan?
Provide a short and direct response. 2.04. What is the ratio of the PFC emissions (in thousand metric tons of CO2 equivalent) of 1990 in Sweden to that in Turkey?
Give a very brief answer. 1.31. What is the ratio of the PFC emissions (in thousand metric tons of CO2 equivalent) of 2000 in Sweden to that in Turkey?
Offer a terse response. 1.3. What is the ratio of the PFC emissions (in thousand metric tons of CO2 equivalent) in 2005 in Sweden to that in Turkey?
Your answer should be very brief. 1.32. What is the ratio of the PFC emissions (in thousand metric tons of CO2 equivalent) of 2008 in Sweden to that in Turkey?
Make the answer very short. 1.14. What is the ratio of the PFC emissions (in thousand metric tons of CO2 equivalent) in 1990 in Switzerland to that in Tajikistan?
Offer a very short reply. 0.11. What is the ratio of the PFC emissions (in thousand metric tons of CO2 equivalent) of 2000 in Switzerland to that in Tajikistan?
Offer a very short reply. 0.12. What is the ratio of the PFC emissions (in thousand metric tons of CO2 equivalent) of 2005 in Switzerland to that in Tajikistan?
Provide a short and direct response. 0.17. What is the ratio of the PFC emissions (in thousand metric tons of CO2 equivalent) in 2008 in Switzerland to that in Tajikistan?
Give a very brief answer. 0.21. What is the ratio of the PFC emissions (in thousand metric tons of CO2 equivalent) in 1990 in Switzerland to that in Turkey?
Offer a terse response. 0.58. What is the ratio of the PFC emissions (in thousand metric tons of CO2 equivalent) of 2000 in Switzerland to that in Turkey?
Offer a very short reply. 0.18. What is the ratio of the PFC emissions (in thousand metric tons of CO2 equivalent) in 2005 in Switzerland to that in Turkey?
Your response must be concise. 0.11. What is the ratio of the PFC emissions (in thousand metric tons of CO2 equivalent) of 2008 in Switzerland to that in Turkey?
Ensure brevity in your answer.  0.12. What is the ratio of the PFC emissions (in thousand metric tons of CO2 equivalent) in 1990 in Tajikistan to that in Turkey?
Ensure brevity in your answer.  5.14. What is the ratio of the PFC emissions (in thousand metric tons of CO2 equivalent) in 2000 in Tajikistan to that in Turkey?
Provide a short and direct response. 1.43. What is the ratio of the PFC emissions (in thousand metric tons of CO2 equivalent) of 2005 in Tajikistan to that in Turkey?
Provide a short and direct response. 0.68. What is the ratio of the PFC emissions (in thousand metric tons of CO2 equivalent) of 2008 in Tajikistan to that in Turkey?
Make the answer very short. 0.56. What is the difference between the highest and the second highest PFC emissions (in thousand metric tons of CO2 equivalent) in 1990?
Offer a terse response. 981.3. What is the difference between the highest and the second highest PFC emissions (in thousand metric tons of CO2 equivalent) in 2000?
Your answer should be compact. 1488.3. What is the difference between the highest and the second highest PFC emissions (in thousand metric tons of CO2 equivalent) in 2005?
Ensure brevity in your answer.  1288.7. What is the difference between the highest and the second highest PFC emissions (in thousand metric tons of CO2 equivalent) in 2008?
Your answer should be very brief. 1178.7. What is the difference between the highest and the lowest PFC emissions (in thousand metric tons of CO2 equivalent) of 1990?
Offer a terse response. 3471.9. What is the difference between the highest and the lowest PFC emissions (in thousand metric tons of CO2 equivalent) in 2000?
Keep it short and to the point. 2185.9. What is the difference between the highest and the lowest PFC emissions (in thousand metric tons of CO2 equivalent) of 2005?
Provide a short and direct response. 1948.5. What is the difference between the highest and the lowest PFC emissions (in thousand metric tons of CO2 equivalent) in 2008?
Provide a succinct answer. 1784.1. 